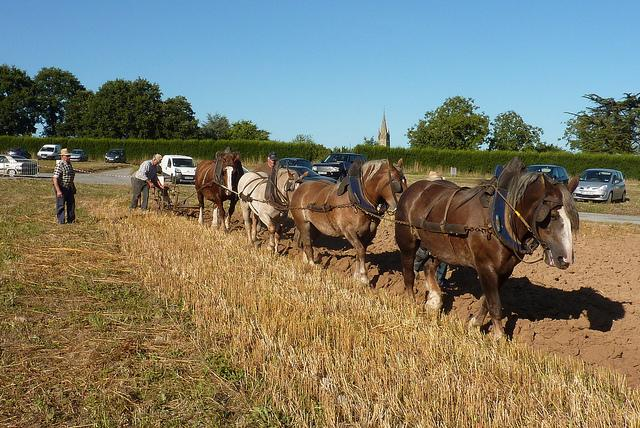Why are horses eyes covered? protect eyes 